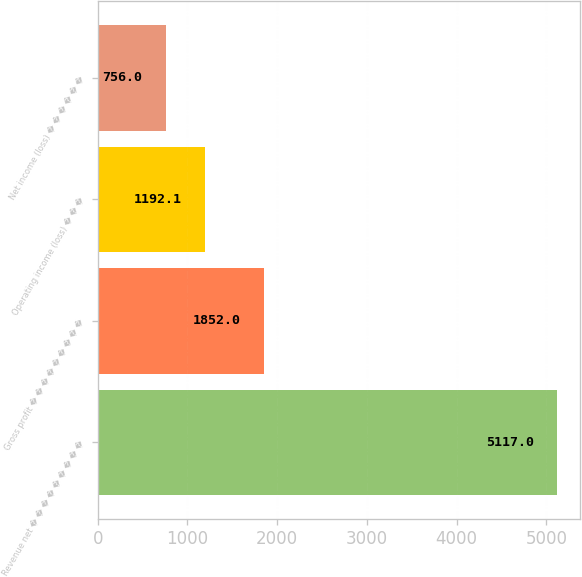Convert chart. <chart><loc_0><loc_0><loc_500><loc_500><bar_chart><fcel>Revenue net � � � � � � � � �<fcel>Gross profit � � � � � � � � �<fcel>Operating income (loss) � � �<fcel>Net income (loss) � � � � � �<nl><fcel>5117<fcel>1852<fcel>1192.1<fcel>756<nl></chart> 